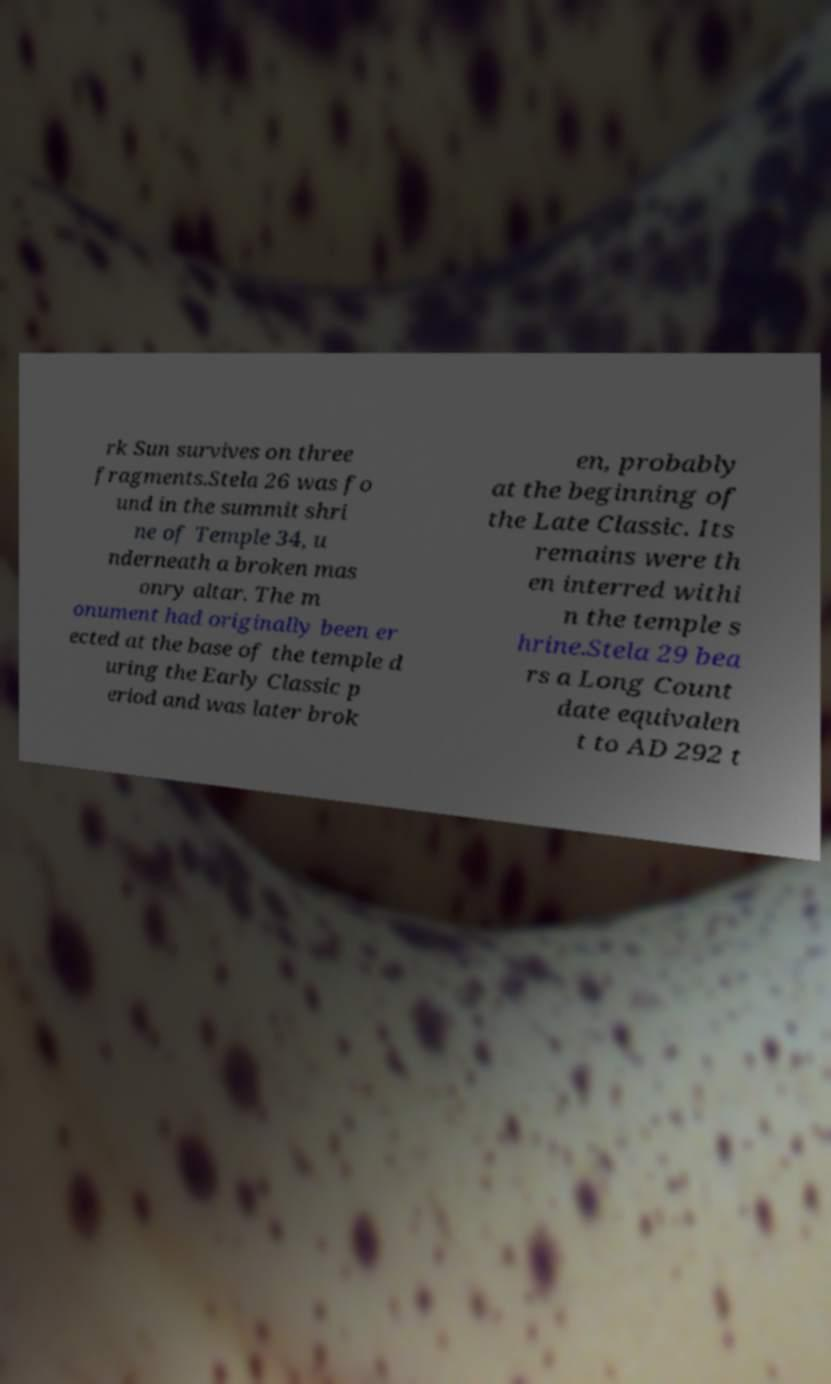Please identify and transcribe the text found in this image. rk Sun survives on three fragments.Stela 26 was fo und in the summit shri ne of Temple 34, u nderneath a broken mas onry altar. The m onument had originally been er ected at the base of the temple d uring the Early Classic p eriod and was later brok en, probably at the beginning of the Late Classic. Its remains were th en interred withi n the temple s hrine.Stela 29 bea rs a Long Count date equivalen t to AD 292 t 